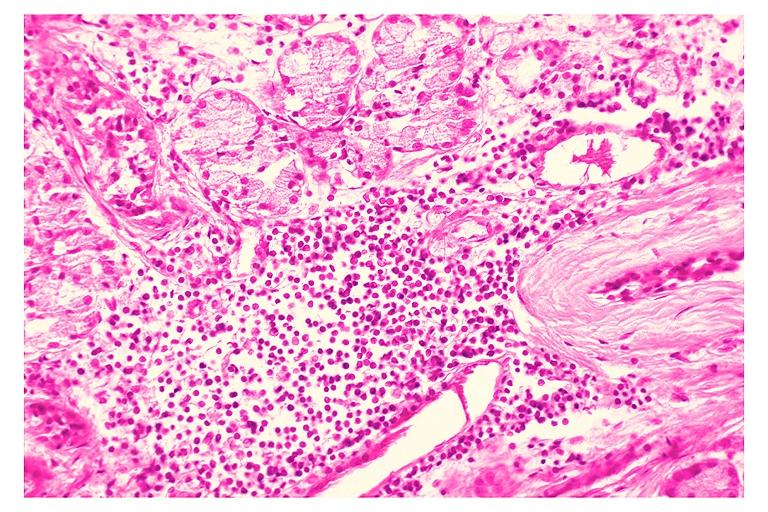what is present?
Answer the question using a single word or phrase. Oral 